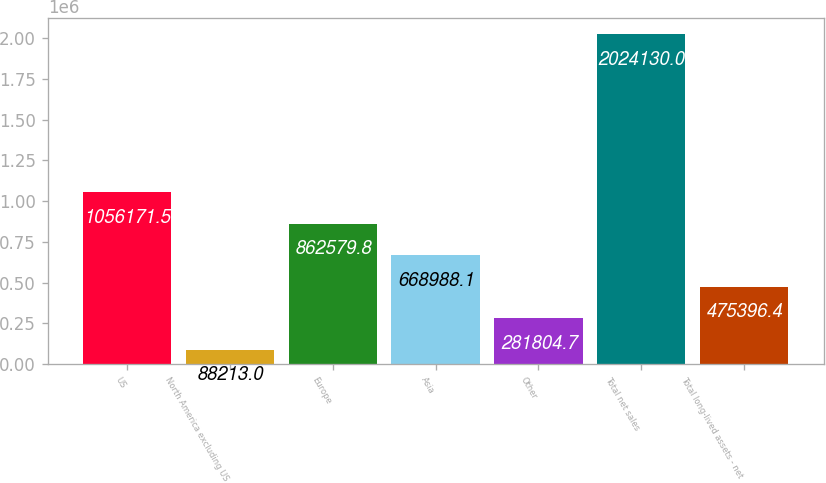Convert chart to OTSL. <chart><loc_0><loc_0><loc_500><loc_500><bar_chart><fcel>US<fcel>North America excluding US<fcel>Europe<fcel>Asia<fcel>Other<fcel>Total net sales<fcel>Total long-lived assets - net<nl><fcel>1.05617e+06<fcel>88213<fcel>862580<fcel>668988<fcel>281805<fcel>2.02413e+06<fcel>475396<nl></chart> 